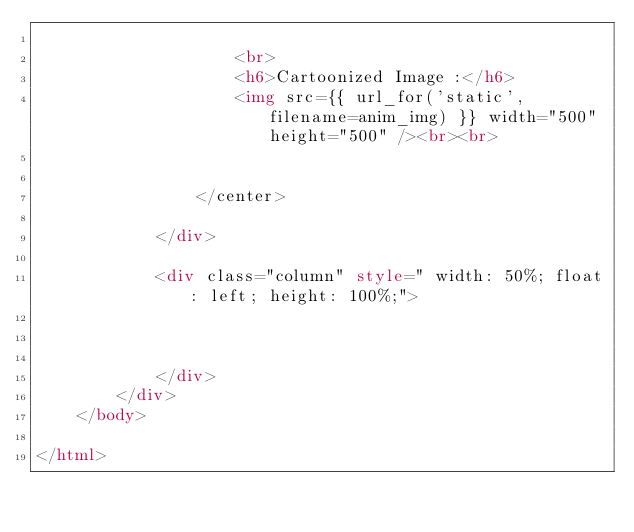<code> <loc_0><loc_0><loc_500><loc_500><_HTML_>                    
                    <br>
                    <h6>Cartoonized Image :</h6>
                    <img src={{ url_for('static', filename=anim_img) }} width="500" height="500" /><br><br>
                    
                    
                </center>
                
            </div>
            
            <div class="column" style=" width: 50%; float: left; height: 100%;">

                

            </div>
        </div>
    </body>
    
</html>

</code> 